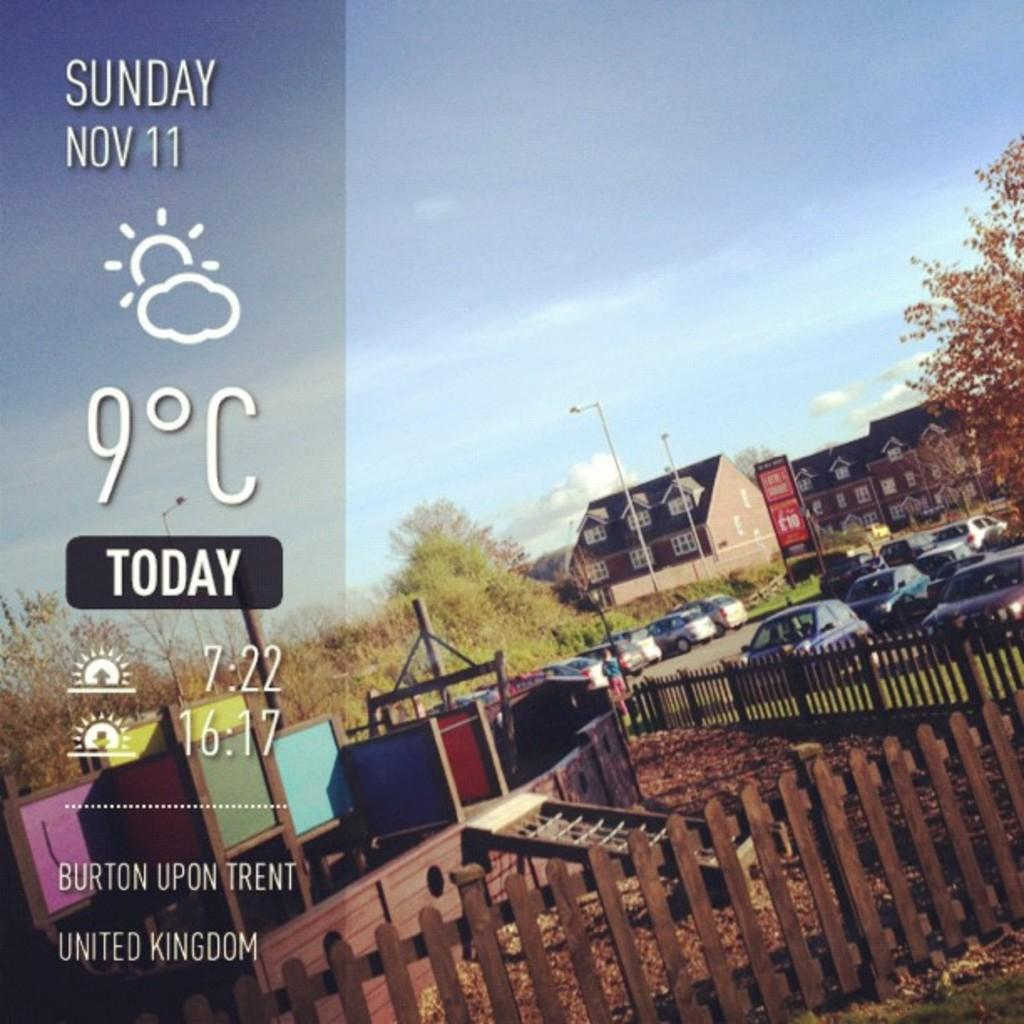<image>
Give a short and clear explanation of the subsequent image. A screen showing the weather for Burton Upon Trent in the UK. 